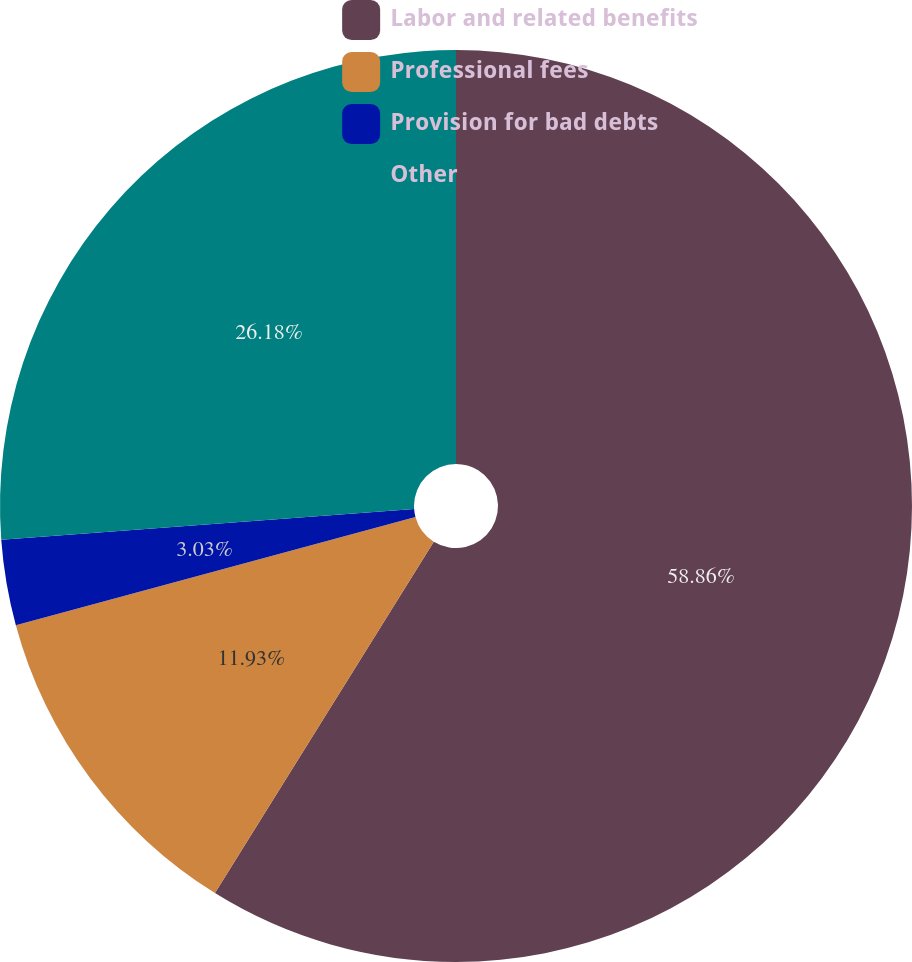Convert chart to OTSL. <chart><loc_0><loc_0><loc_500><loc_500><pie_chart><fcel>Labor and related benefits<fcel>Professional fees<fcel>Provision for bad debts<fcel>Other<nl><fcel>58.87%<fcel>11.93%<fcel>3.03%<fcel>26.18%<nl></chart> 